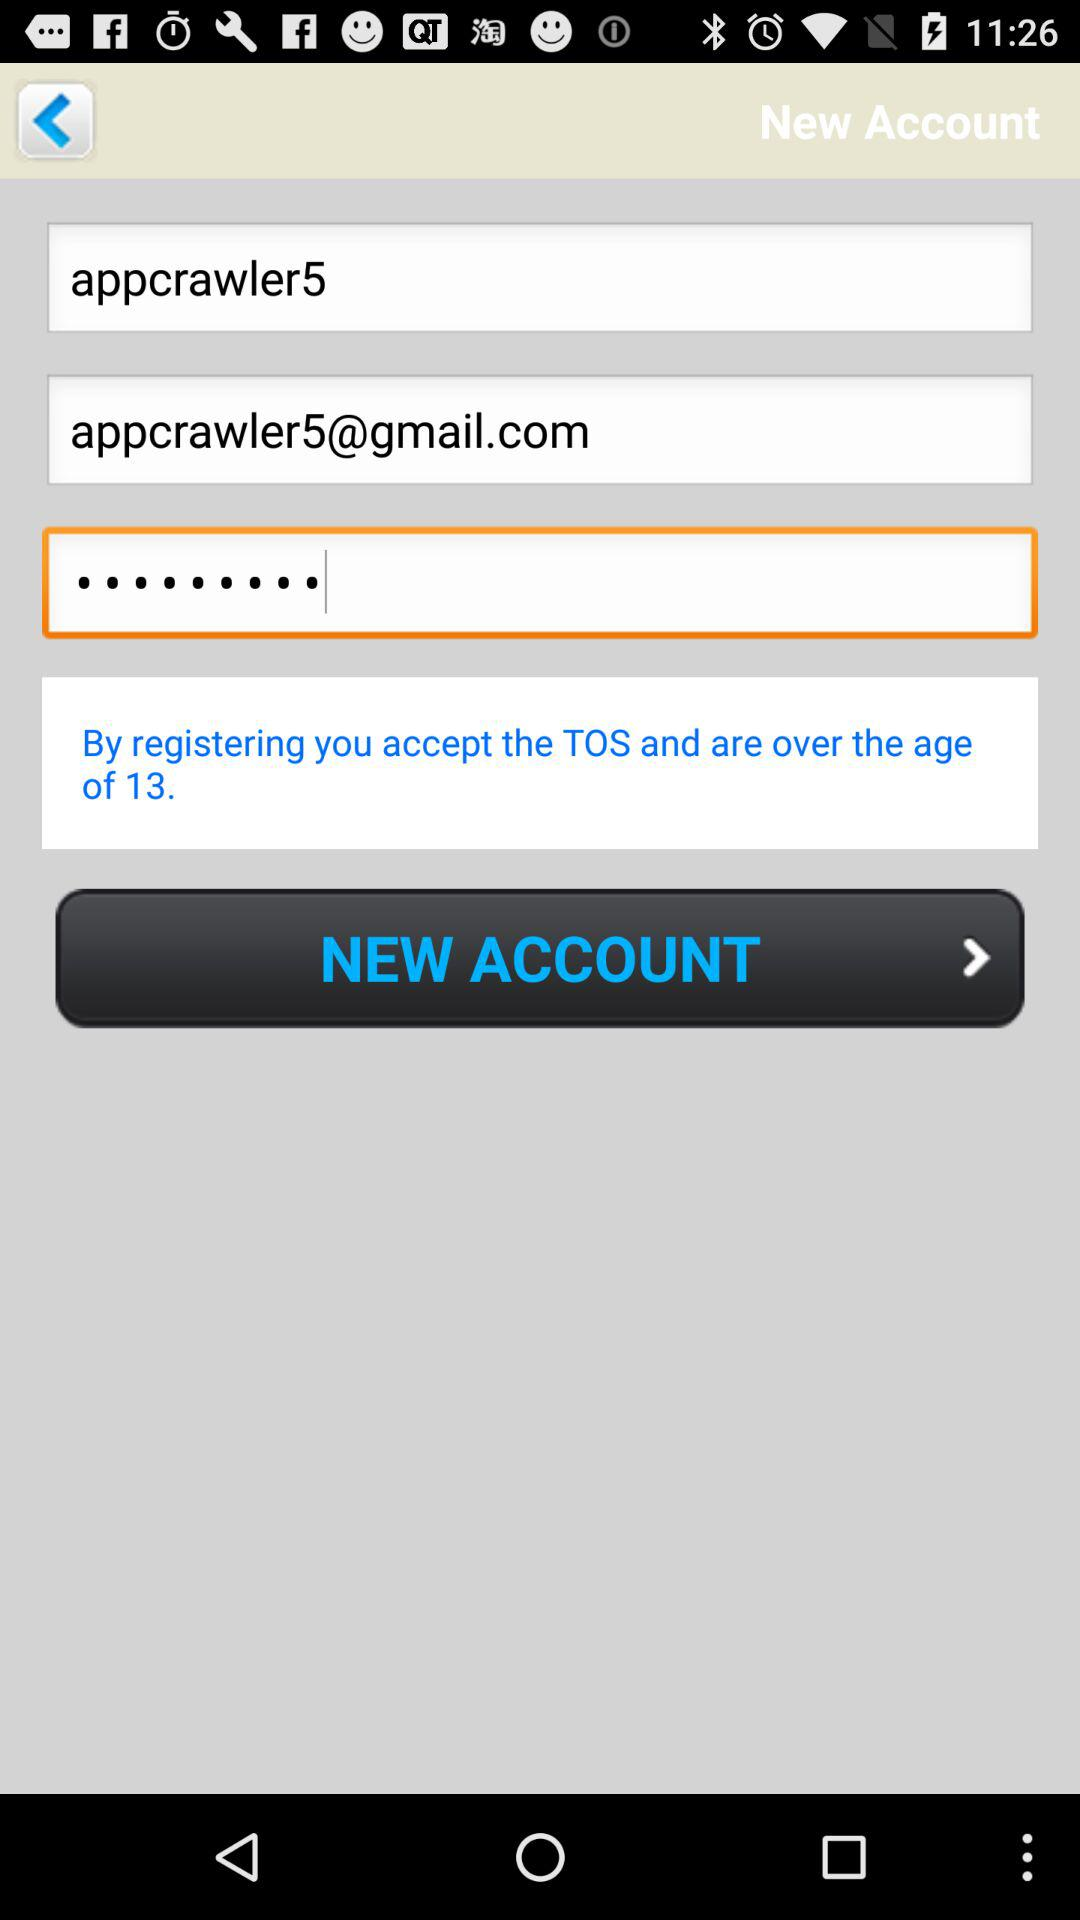What is the minimum age limit? The minimum age limit is 13. 